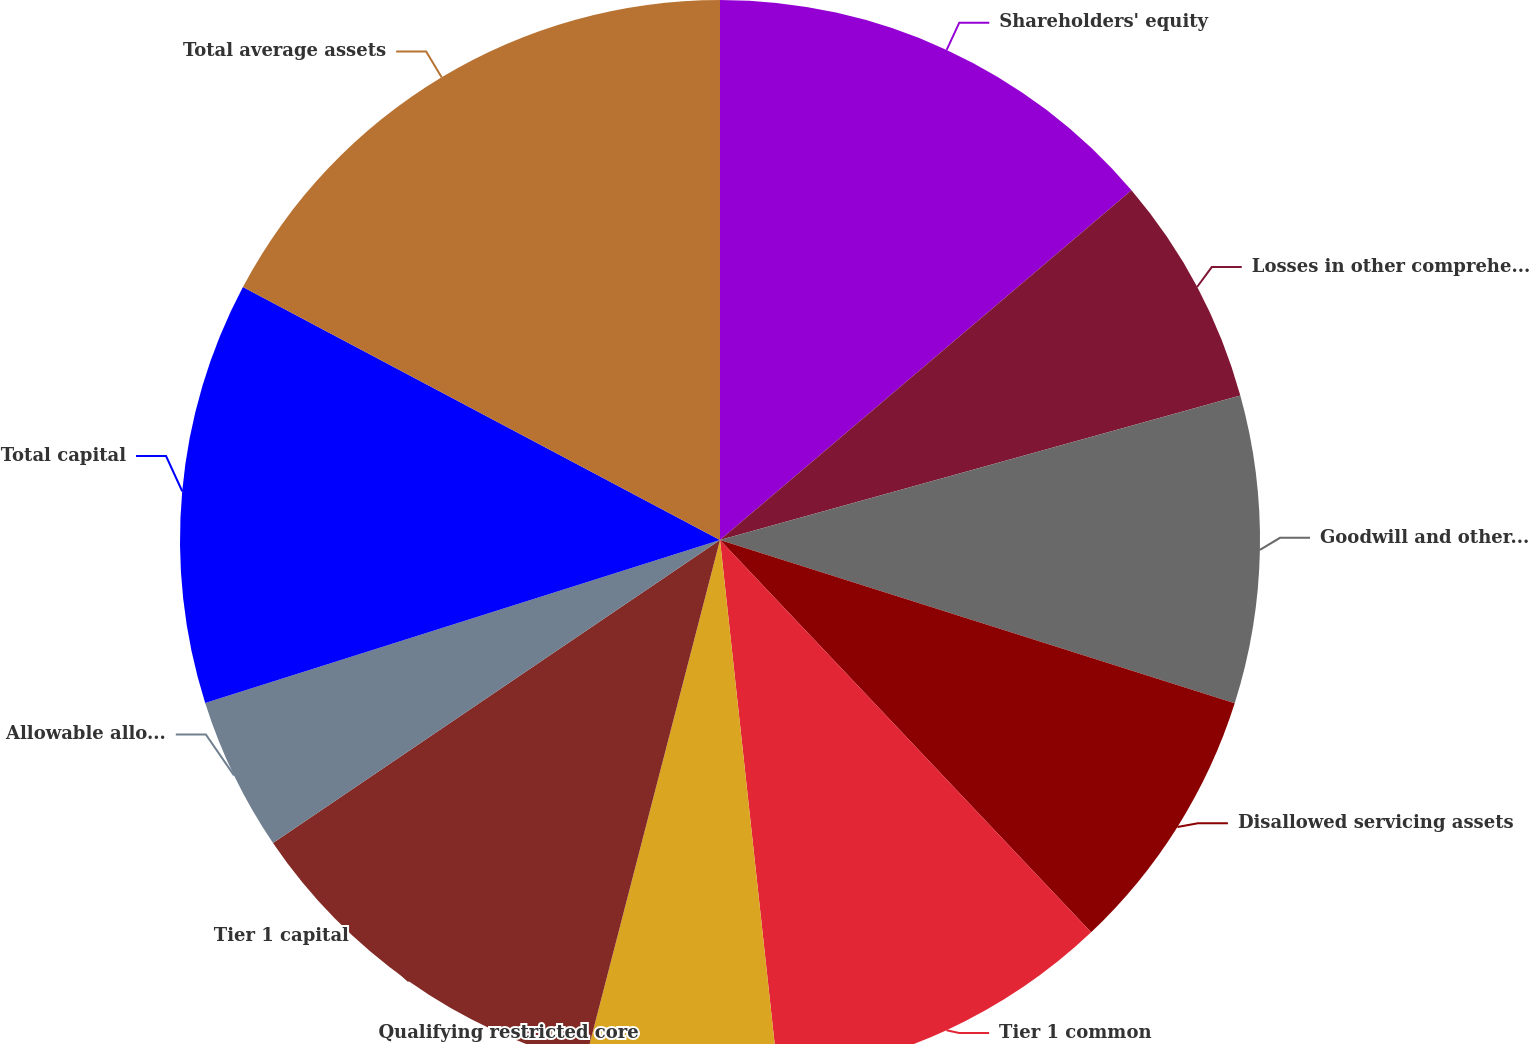Convert chart to OTSL. <chart><loc_0><loc_0><loc_500><loc_500><pie_chart><fcel>Shareholders' equity<fcel>Losses in other comprehensive<fcel>Goodwill and other intangible<fcel>Disallowed servicing assets<fcel>Tier 1 common<fcel>Qualifying restricted core<fcel>Tier 1 capital<fcel>Allowable allowance for loan<fcel>Total capital<fcel>Total average assets<nl><fcel>13.79%<fcel>6.9%<fcel>9.2%<fcel>8.05%<fcel>10.34%<fcel>5.75%<fcel>11.49%<fcel>4.6%<fcel>12.64%<fcel>17.24%<nl></chart> 